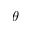<formula> <loc_0><loc_0><loc_500><loc_500>\theta</formula> 